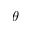<formula> <loc_0><loc_0><loc_500><loc_500>\theta</formula> 